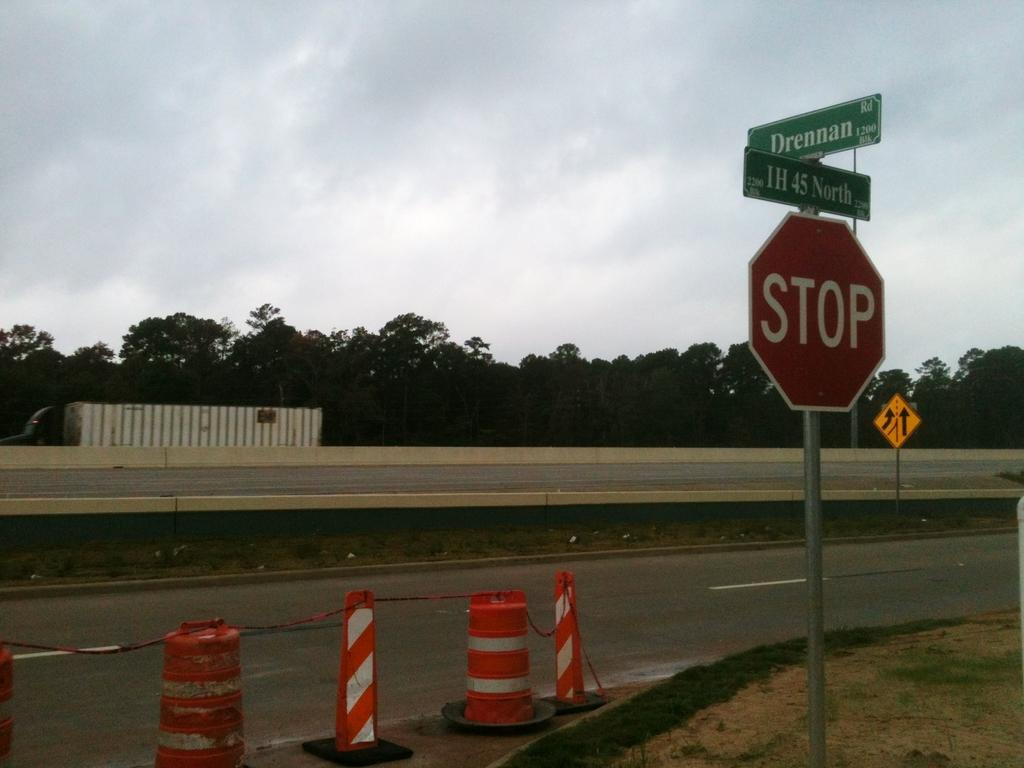<image>
Provide a brief description of the given image. a Stop sign on a street under signs for IH 45 North and Drennan 